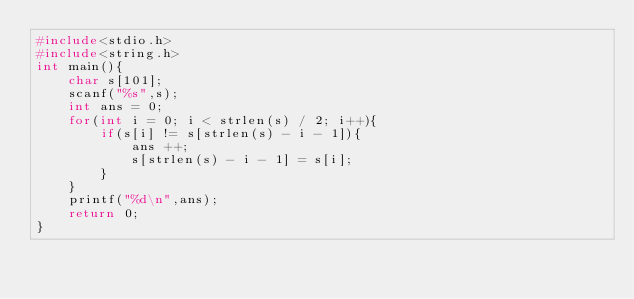<code> <loc_0><loc_0><loc_500><loc_500><_C_>#include<stdio.h>
#include<string.h>
int main(){
    char s[101];
    scanf("%s",s);
    int ans = 0;
    for(int i = 0; i < strlen(s) / 2; i++){
        if(s[i] != s[strlen(s) - i - 1]){
            ans ++;
            s[strlen(s) - i - 1] = s[i];
        }
    }
    printf("%d\n",ans);
    return 0;
}</code> 